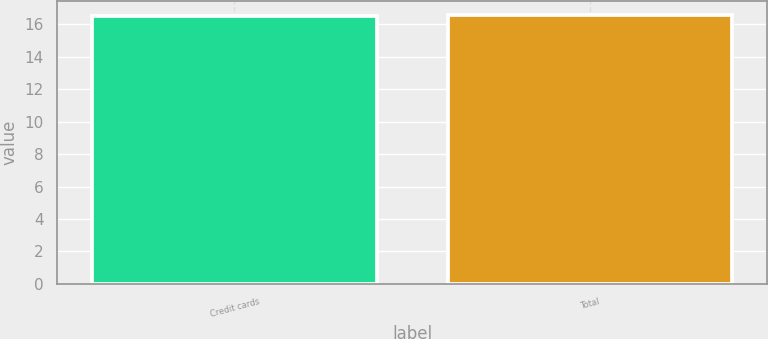Convert chart. <chart><loc_0><loc_0><loc_500><loc_500><bar_chart><fcel>Credit cards<fcel>Total<nl><fcel>16.5<fcel>16.6<nl></chart> 